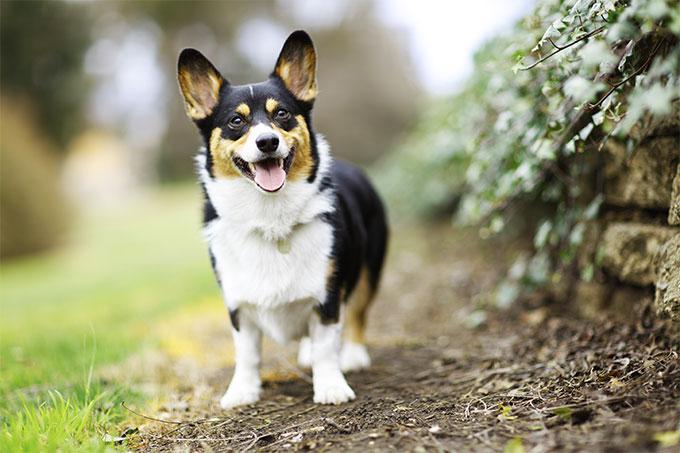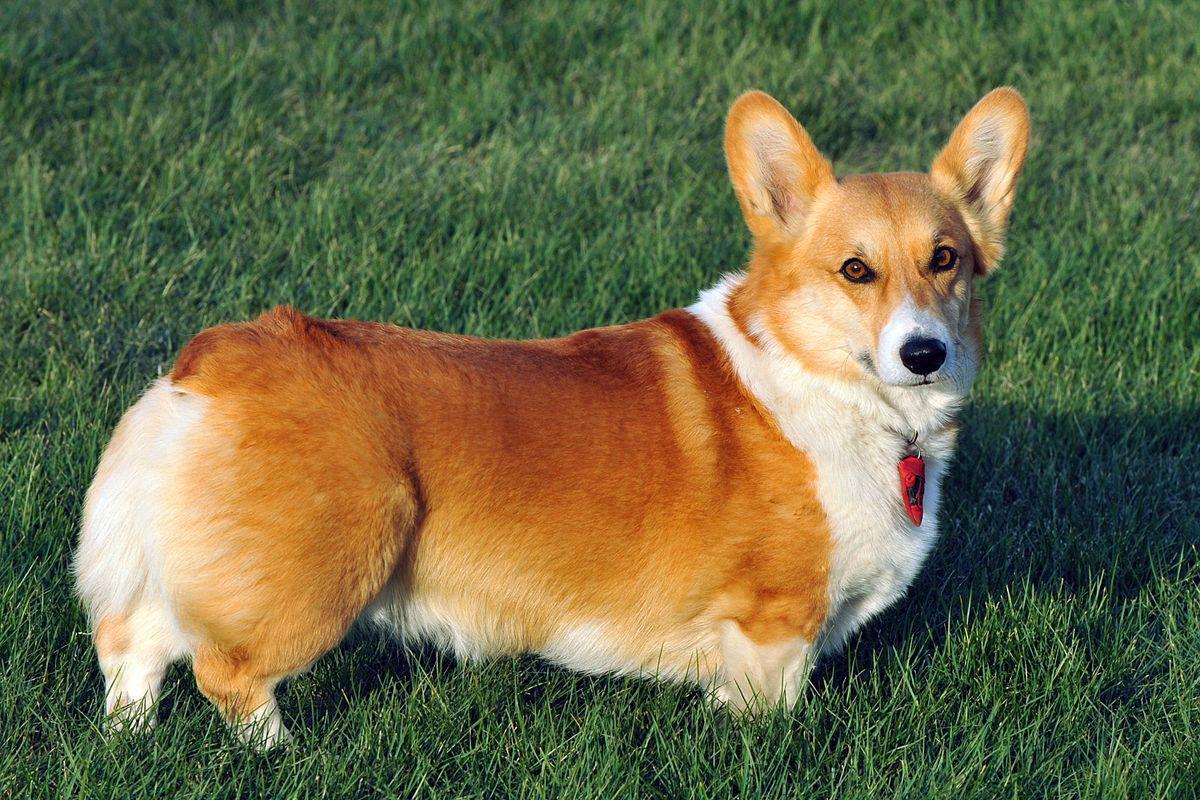The first image is the image on the left, the second image is the image on the right. Analyze the images presented: Is the assertion "Two corgies have their ears pointed upward and their mouths open and smiling with tongues showing." valid? Answer yes or no. No. The first image is the image on the left, the second image is the image on the right. For the images shown, is this caption "An image shows a corgi dog bounding across the grass, with at least one front paw raised." true? Answer yes or no. No. 